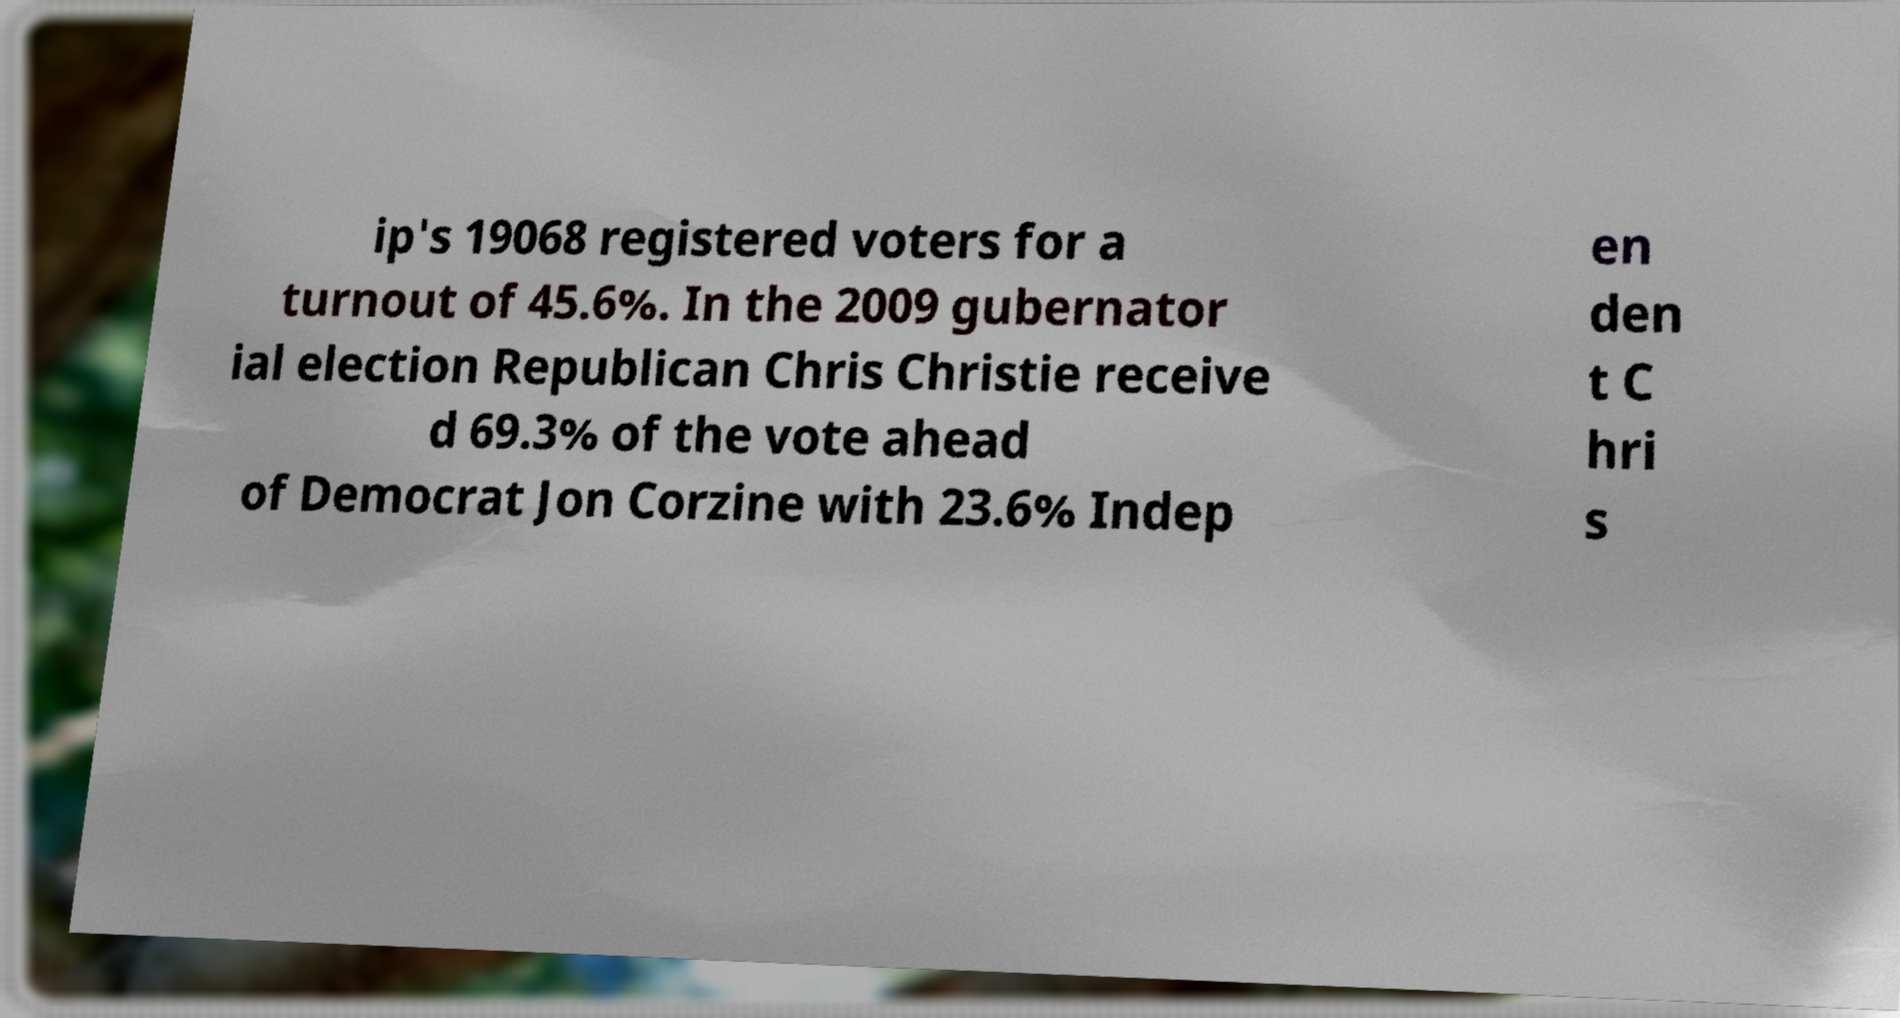Can you read and provide the text displayed in the image?This photo seems to have some interesting text. Can you extract and type it out for me? ip's 19068 registered voters for a turnout of 45.6%. In the 2009 gubernator ial election Republican Chris Christie receive d 69.3% of the vote ahead of Democrat Jon Corzine with 23.6% Indep en den t C hri s 